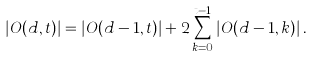<formula> <loc_0><loc_0><loc_500><loc_500>| O ( d , t ) | = | O ( d - 1 , t ) | + 2 \sum _ { k = 0 } ^ { t - 1 } | O ( d - 1 , k ) | \, .</formula> 